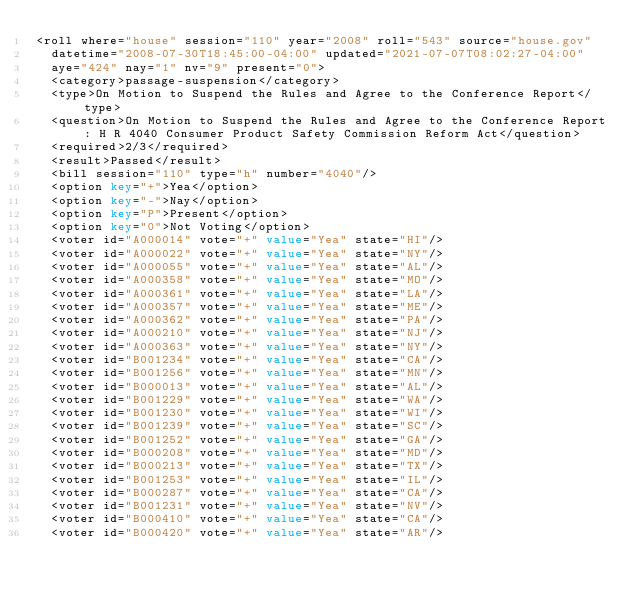<code> <loc_0><loc_0><loc_500><loc_500><_XML_><roll where="house" session="110" year="2008" roll="543" source="house.gov"
  datetime="2008-07-30T18:45:00-04:00" updated="2021-07-07T08:02:27-04:00"
  aye="424" nay="1" nv="9" present="0">
  <category>passage-suspension</category>
  <type>On Motion to Suspend the Rules and Agree to the Conference Report</type>
  <question>On Motion to Suspend the Rules and Agree to the Conference Report: H R 4040 Consumer Product Safety Commission Reform Act</question>
  <required>2/3</required>
  <result>Passed</result>
  <bill session="110" type="h" number="4040"/>
  <option key="+">Yea</option>
  <option key="-">Nay</option>
  <option key="P">Present</option>
  <option key="0">Not Voting</option>
  <voter id="A000014" vote="+" value="Yea" state="HI"/>
  <voter id="A000022" vote="+" value="Yea" state="NY"/>
  <voter id="A000055" vote="+" value="Yea" state="AL"/>
  <voter id="A000358" vote="+" value="Yea" state="MO"/>
  <voter id="A000361" vote="+" value="Yea" state="LA"/>
  <voter id="A000357" vote="+" value="Yea" state="ME"/>
  <voter id="A000362" vote="+" value="Yea" state="PA"/>
  <voter id="A000210" vote="+" value="Yea" state="NJ"/>
  <voter id="A000363" vote="+" value="Yea" state="NY"/>
  <voter id="B001234" vote="+" value="Yea" state="CA"/>
  <voter id="B001256" vote="+" value="Yea" state="MN"/>
  <voter id="B000013" vote="+" value="Yea" state="AL"/>
  <voter id="B001229" vote="+" value="Yea" state="WA"/>
  <voter id="B001230" vote="+" value="Yea" state="WI"/>
  <voter id="B001239" vote="+" value="Yea" state="SC"/>
  <voter id="B001252" vote="+" value="Yea" state="GA"/>
  <voter id="B000208" vote="+" value="Yea" state="MD"/>
  <voter id="B000213" vote="+" value="Yea" state="TX"/>
  <voter id="B001253" vote="+" value="Yea" state="IL"/>
  <voter id="B000287" vote="+" value="Yea" state="CA"/>
  <voter id="B001231" vote="+" value="Yea" state="NV"/>
  <voter id="B000410" vote="+" value="Yea" state="CA"/>
  <voter id="B000420" vote="+" value="Yea" state="AR"/></code> 